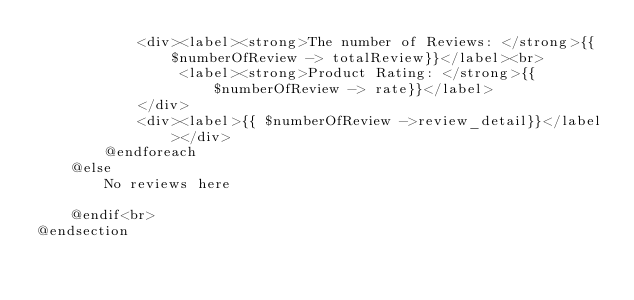<code> <loc_0><loc_0><loc_500><loc_500><_PHP_>            <div><label><strong>The number of Reviews: </strong>{{$numberOfReview -> totalReview}}</label><br>
                 <label><strong>Product Rating: </strong>{{$numberOfReview -> rate}}</label>
            </div>
            <div><label>{{ $numberOfReview ->review_detail}}</label></div>
        @endforeach
    @else
        No reviews here
    
    @endif<br>
@endsection</code> 